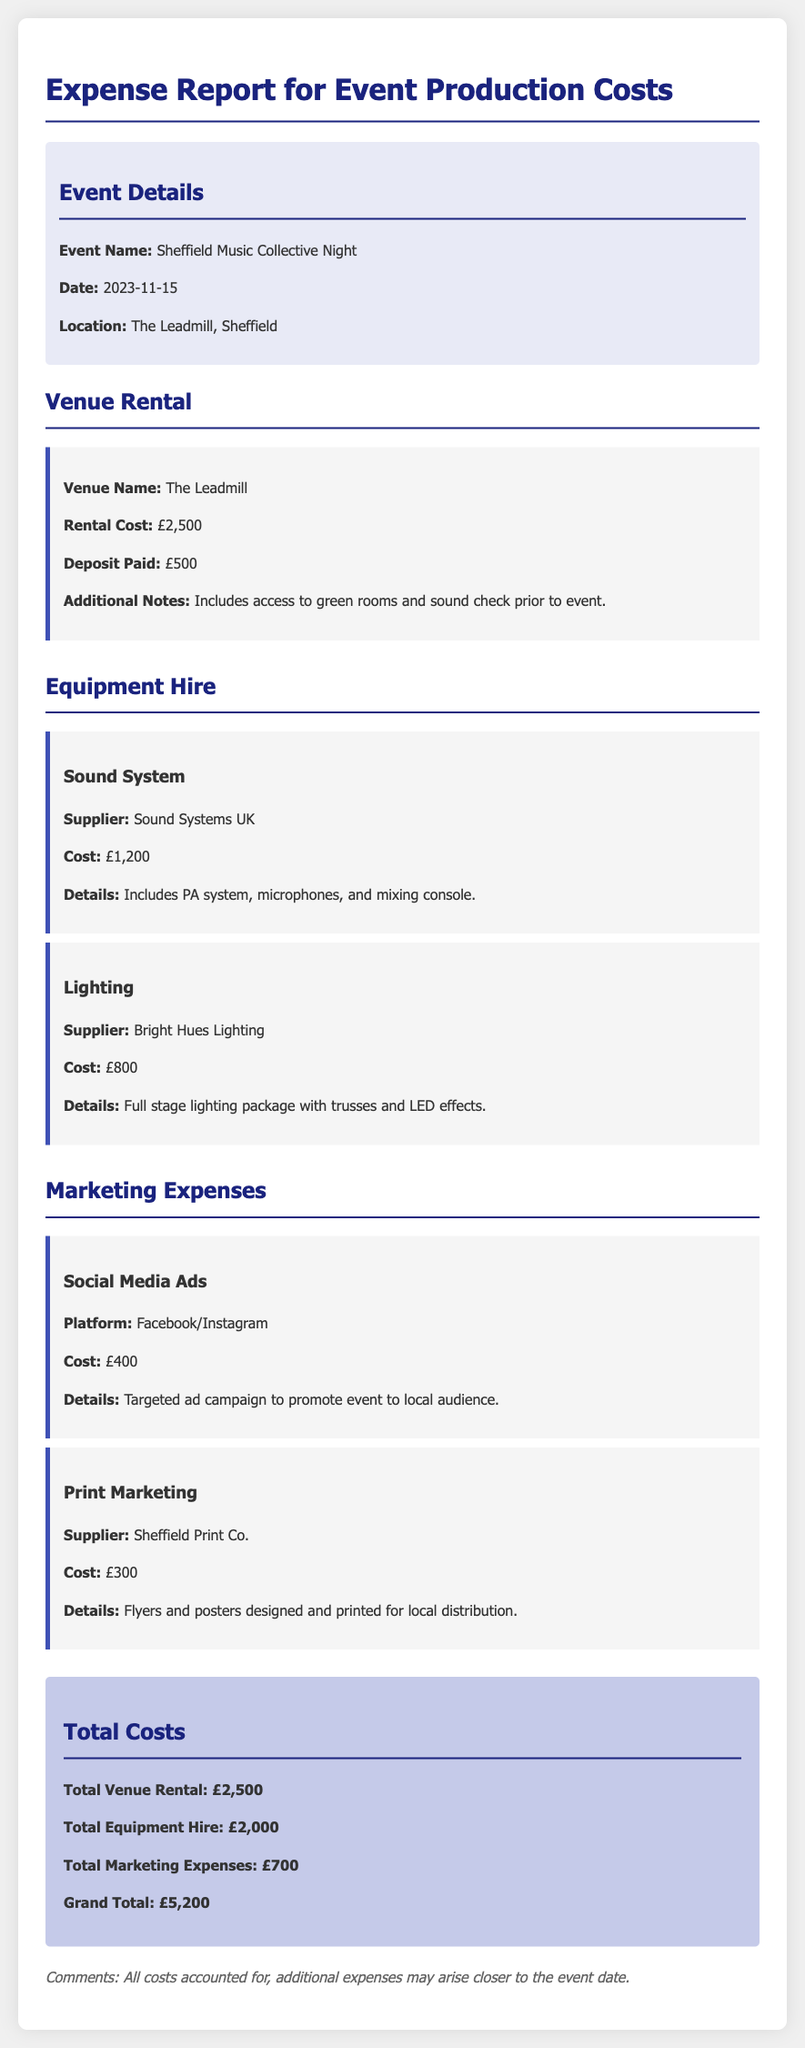What is the event name? The document specifies the name of the event being reported on.
Answer: Sheffield Music Collective Night What is the total venue rental cost? The total venue rental cost is explicitly stated in the document.
Answer: £2,500 What is the supplier for the sound system? The supplier information for equipment hire is detailed in the document.
Answer: Sound Systems UK What is the total cost for marketing expenses? The total marketing expenses are summed up in the financial report.
Answer: £700 How much was spent on print marketing? The document shows specific costs for marketing activities, including print marketing.
Answer: £300 What is the grand total of all expenses? The grand total is clearly outlined in the total costs section of the report.
Answer: £5,200 What additional services are included in the venue rental? The document lists notes regarding the venue rental service details.
Answer: Access to green rooms and sound check prior to event Which supplier provided the lighting equipment? This question focuses on the supplier for the lighting equipment mentioned in the report.
Answer: Bright Hues Lighting What advertising platforms were used for marketing? The document specifies the platforms used for the social media advertising campaign.
Answer: Facebook/Instagram 